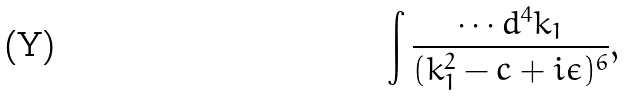<formula> <loc_0><loc_0><loc_500><loc_500>\int \frac { \cdots d ^ { 4 } k _ { 1 } } { ( k _ { 1 } ^ { 2 } - c + i \epsilon ) ^ { 6 } } ,</formula> 